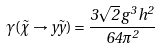<formula> <loc_0><loc_0><loc_500><loc_500>\gamma ( \tilde { \chi } \to y \tilde { y } ) = \frac { 3 \sqrt { 2 } \, g ^ { 3 } \, h ^ { 2 } } { 6 4 \pi ^ { 2 } }</formula> 